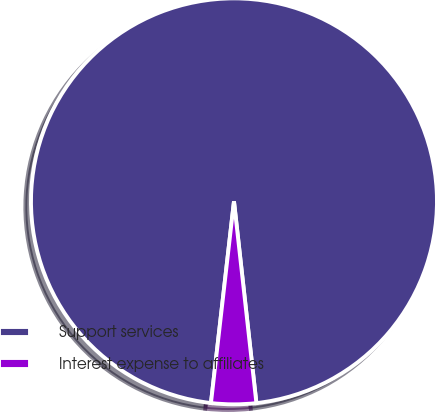Convert chart. <chart><loc_0><loc_0><loc_500><loc_500><pie_chart><fcel>Support services<fcel>Interest expense to affiliates<nl><fcel>96.43%<fcel>3.57%<nl></chart> 